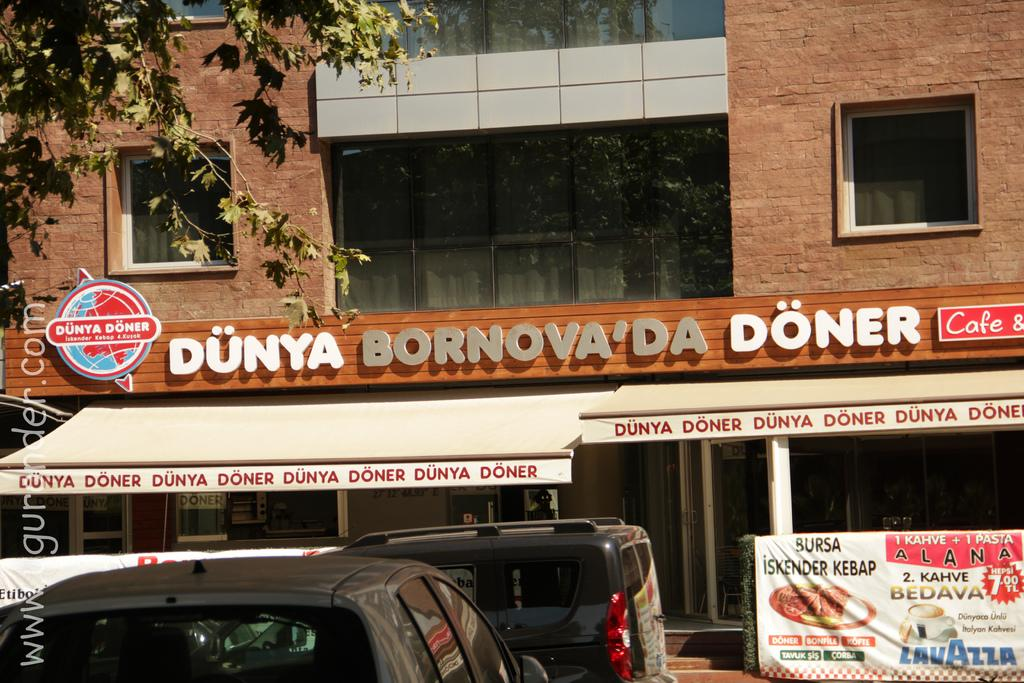What types of objects are located at the bottom of the image? There are vehicles at the bottom of the image. What is also present at the bottom of the image? There is a banner at the bottom of the image. What can be seen in the background of the image? There is a building, text written on a wall, windows, and glass doors in the background. Can you describe the vegetation in the image? There is a tree on the left side of the image. Can you see the boy smiling in the image? There is no boy present in the image, so it is not possible to determine if he is smiling or not. What type of boot is hanging from the tree in the image? There is no boot hanging from the tree in the image; only a tree is present on the left side. 